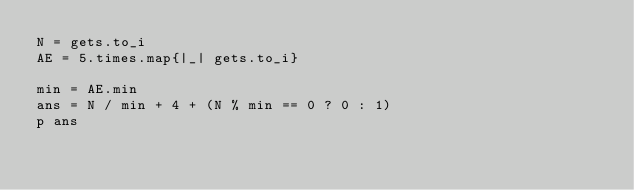<code> <loc_0><loc_0><loc_500><loc_500><_Ruby_>N = gets.to_i
AE = 5.times.map{|_| gets.to_i}

min = AE.min
ans = N / min + 4 + (N % min == 0 ? 0 : 1)
p ans</code> 